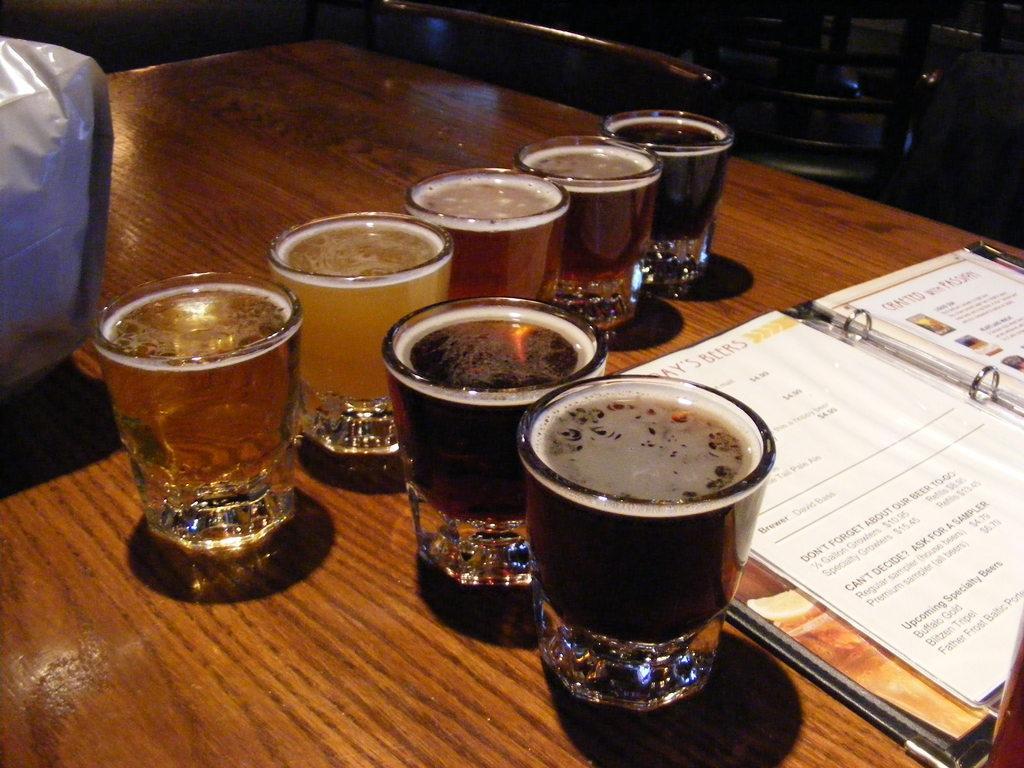In one or two sentences, can you explain what this image depicts? In this image I see the brown color table on which there are 7 glasses and I see a book over here on which there are papers and I see something is written. In the background I see few chairs and I see the white color thing over here. 